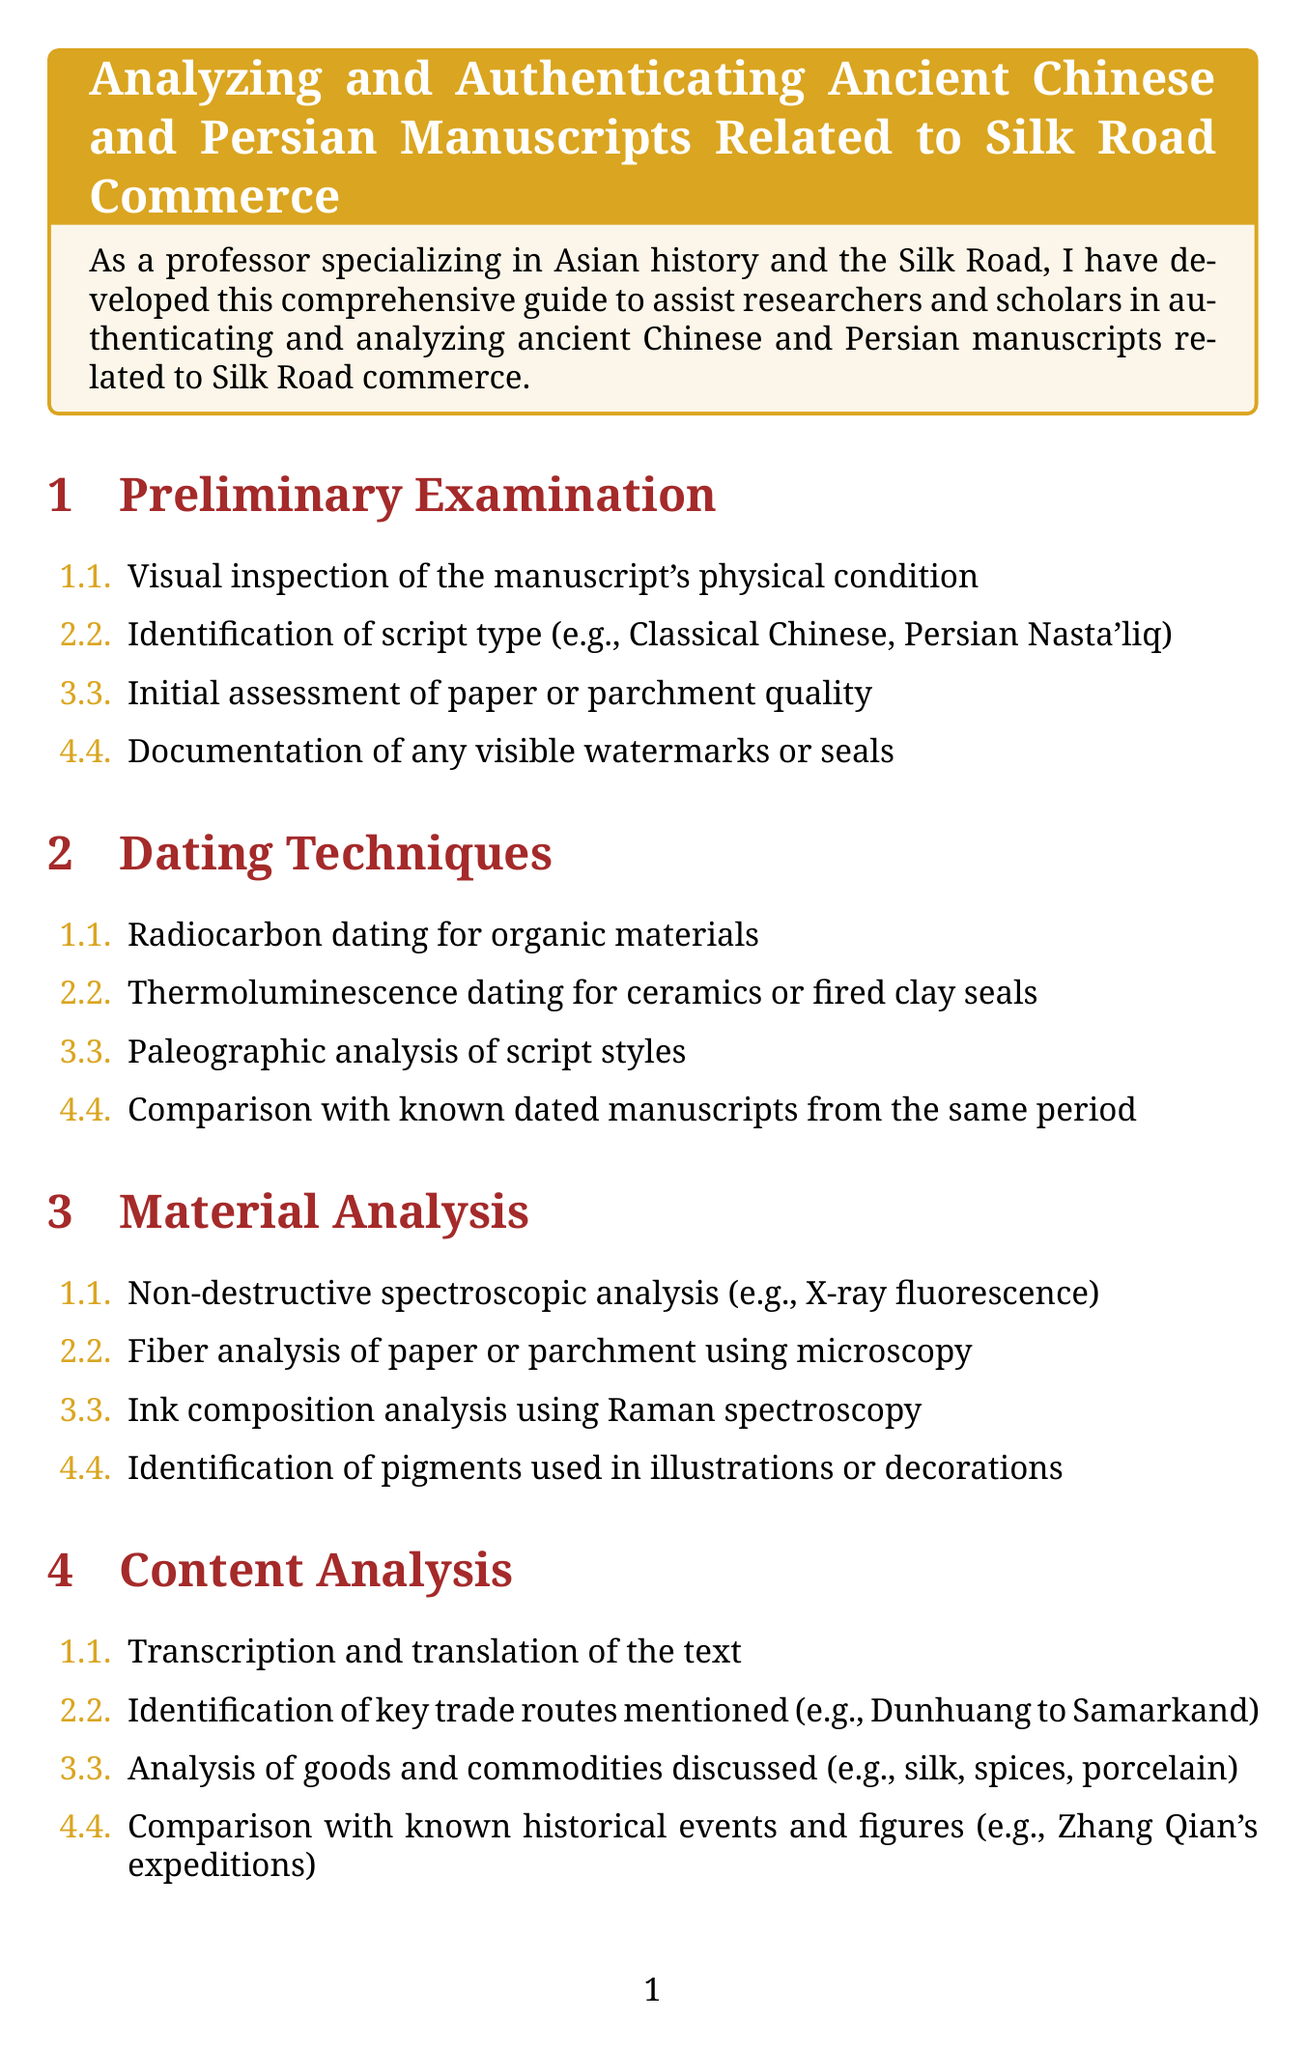What is the title of the guide? The title of the guide is stated clearly at the beginning of the document.
Answer: Analyzing and Authenticating Ancient Chinese and Persian Manuscripts Related to Silk Road Commerce What step involves visual inspection? The first step in the guide's preliminary examination is to visually inspect the manuscript's condition.
Answer: Visual inspection of the manuscript's physical condition What dating technique uses organic materials? The dating technique that is specifically mentioned for organic materials is stated in the dating techniques section.
Answer: Radiocarbon dating Which analysis method is used for ink composition? The method for analyzing ink composition is listed in the material analysis section.
Answer: Raman spectroscopy What historical event is correlated in the historical context section? The document mentions specific historical events to correlate with the analysis in the historical context section.
Answer: An Lushan Rebellion What is required in the authentication processes? The authentication process includes specific steps that must be verified according to the document.
Answer: Verification of provenance and chain of custody What comparison is suggested in content analysis? The content analysis section asks for a comparison with known historical events and figures.
Answer: Comparison with known historical events and figures What is the last section of the guide? The final section of the document encapsulates the main actions to be taken after analysis.
Answer: Interpretation and Contextualization 